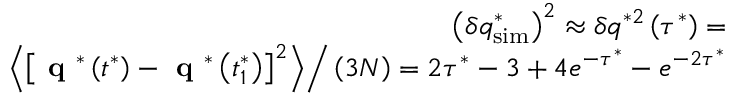Convert formula to latex. <formula><loc_0><loc_0><loc_500><loc_500>\begin{array} { r } { \left ( \delta q _ { s i m } ^ { * } \right ) ^ { 2 } \approx \delta q ^ { * 2 } \left ( \tau ^ { * } \right ) = } \\ { \left < \left [ q ^ { * } \left ( t ^ { * } \right ) - q ^ { * } \left ( t _ { 1 } ^ { * } \right ) \right ] ^ { 2 } \right > \right / \left ( 3 N \right ) = 2 \tau ^ { * } - 3 + 4 e ^ { - \tau ^ { * } } - e ^ { - 2 \tau ^ { * } } } \end{array}</formula> 